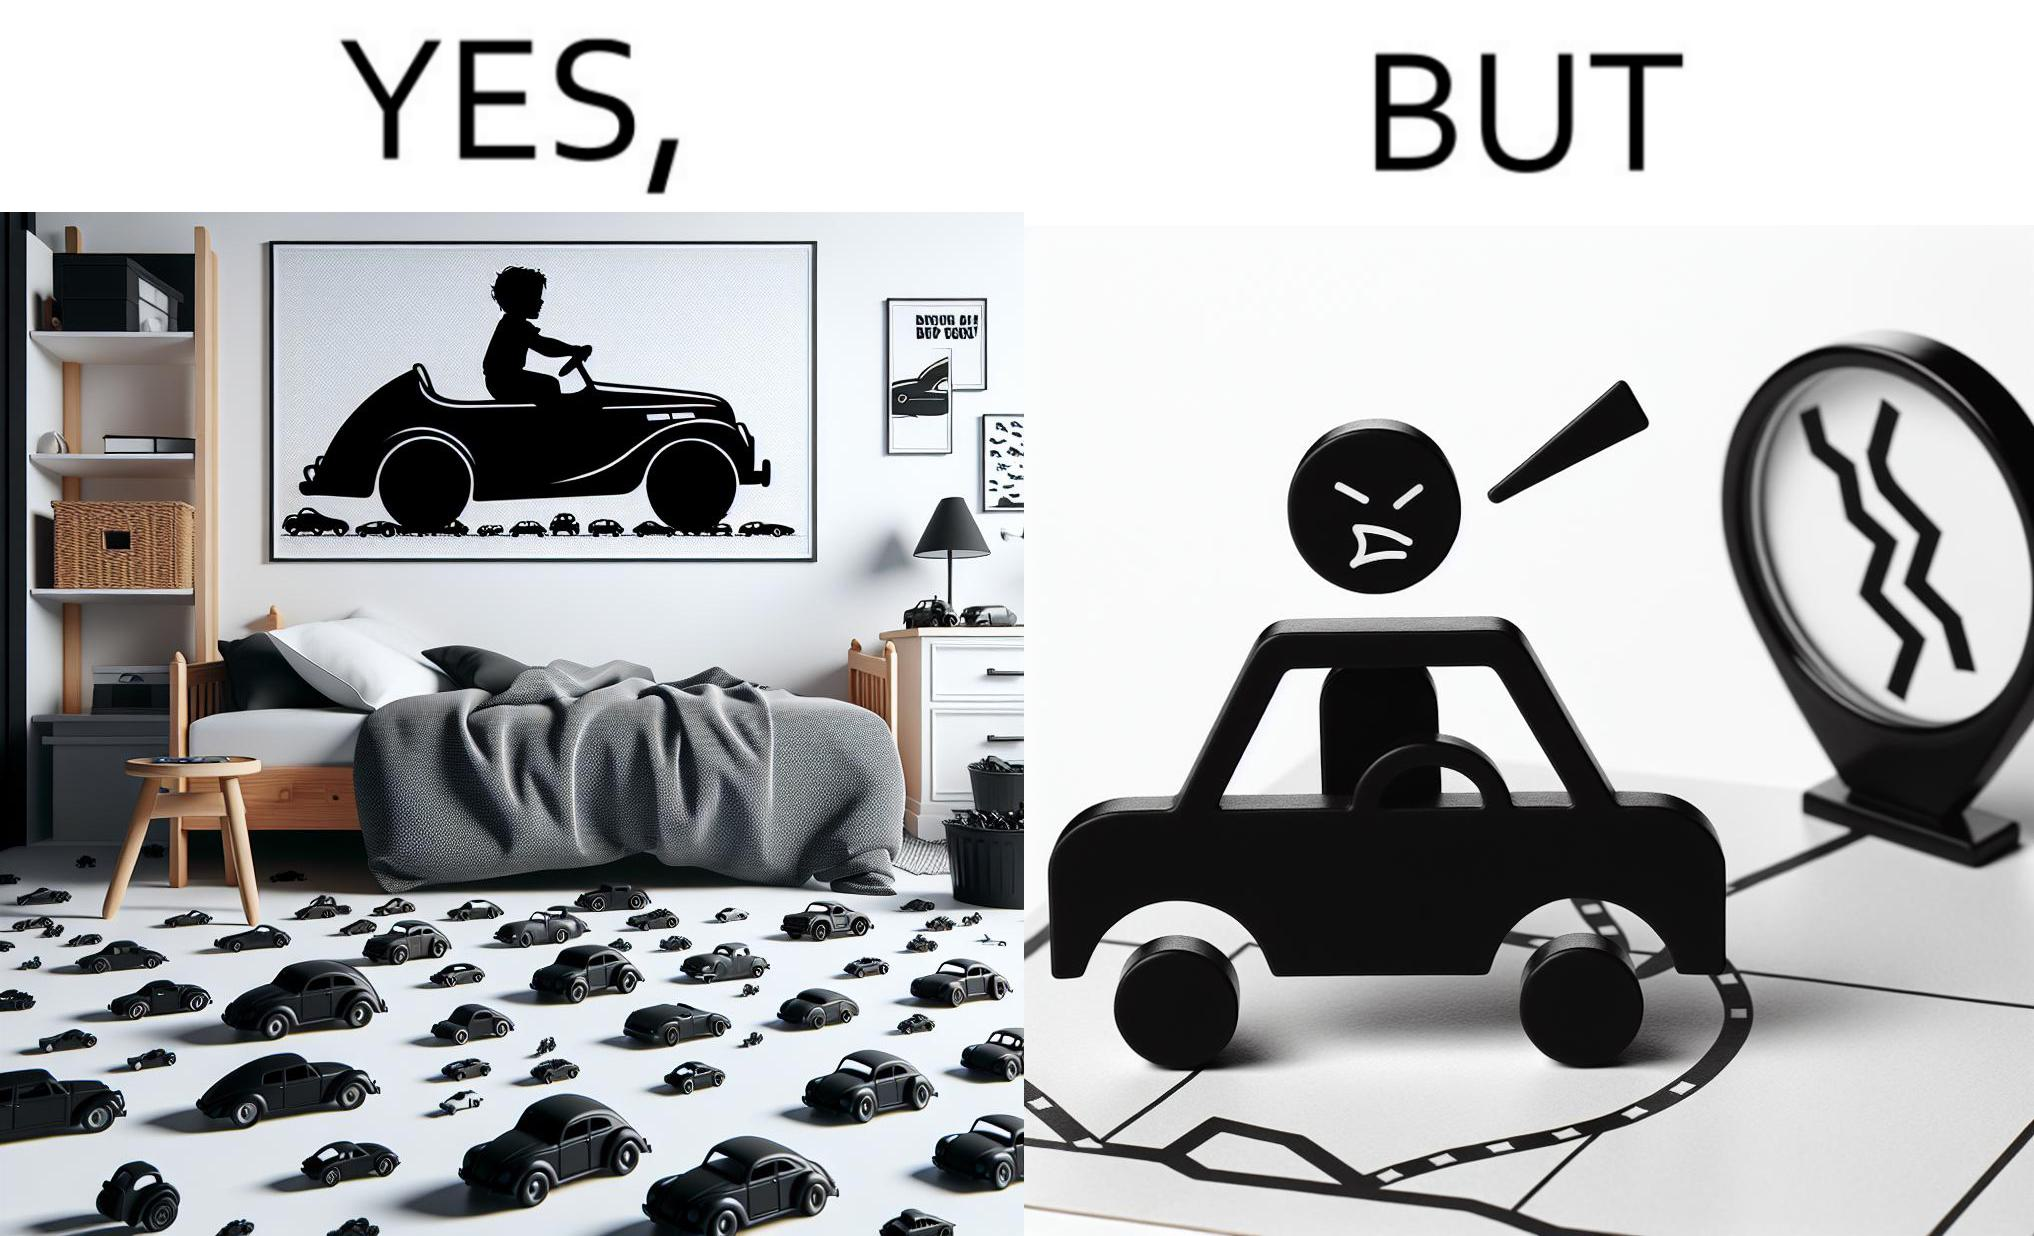Describe the content of this image. The image is funny beaucse while the person as a child enjoyed being around cars, had various small toy cars and even rode a bigger toy car, as as grown up he does not enjoy being in a car during a traffic jam while he is driving . 